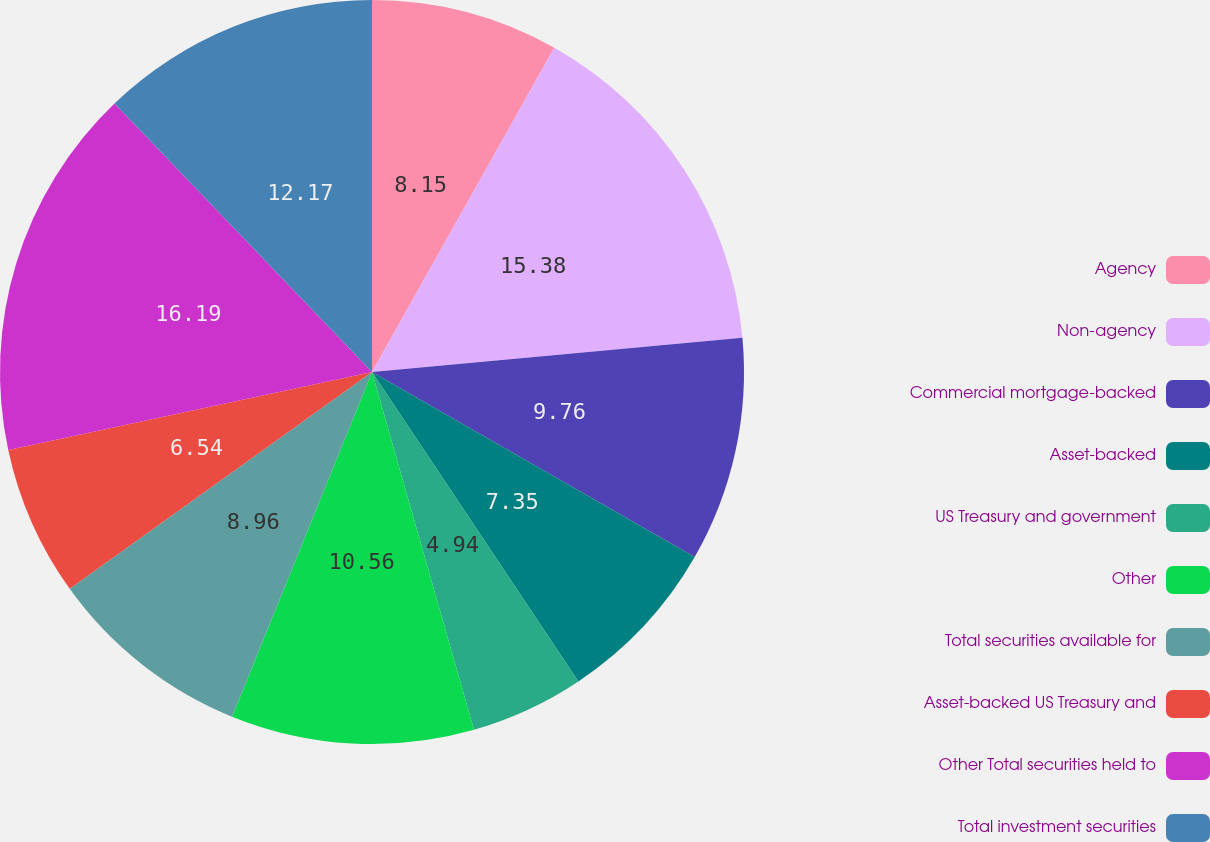Convert chart. <chart><loc_0><loc_0><loc_500><loc_500><pie_chart><fcel>Agency<fcel>Non-agency<fcel>Commercial mortgage-backed<fcel>Asset-backed<fcel>US Treasury and government<fcel>Other<fcel>Total securities available for<fcel>Asset-backed US Treasury and<fcel>Other Total securities held to<fcel>Total investment securities<nl><fcel>8.15%<fcel>15.38%<fcel>9.76%<fcel>7.35%<fcel>4.94%<fcel>10.56%<fcel>8.96%<fcel>6.54%<fcel>16.19%<fcel>12.17%<nl></chart> 